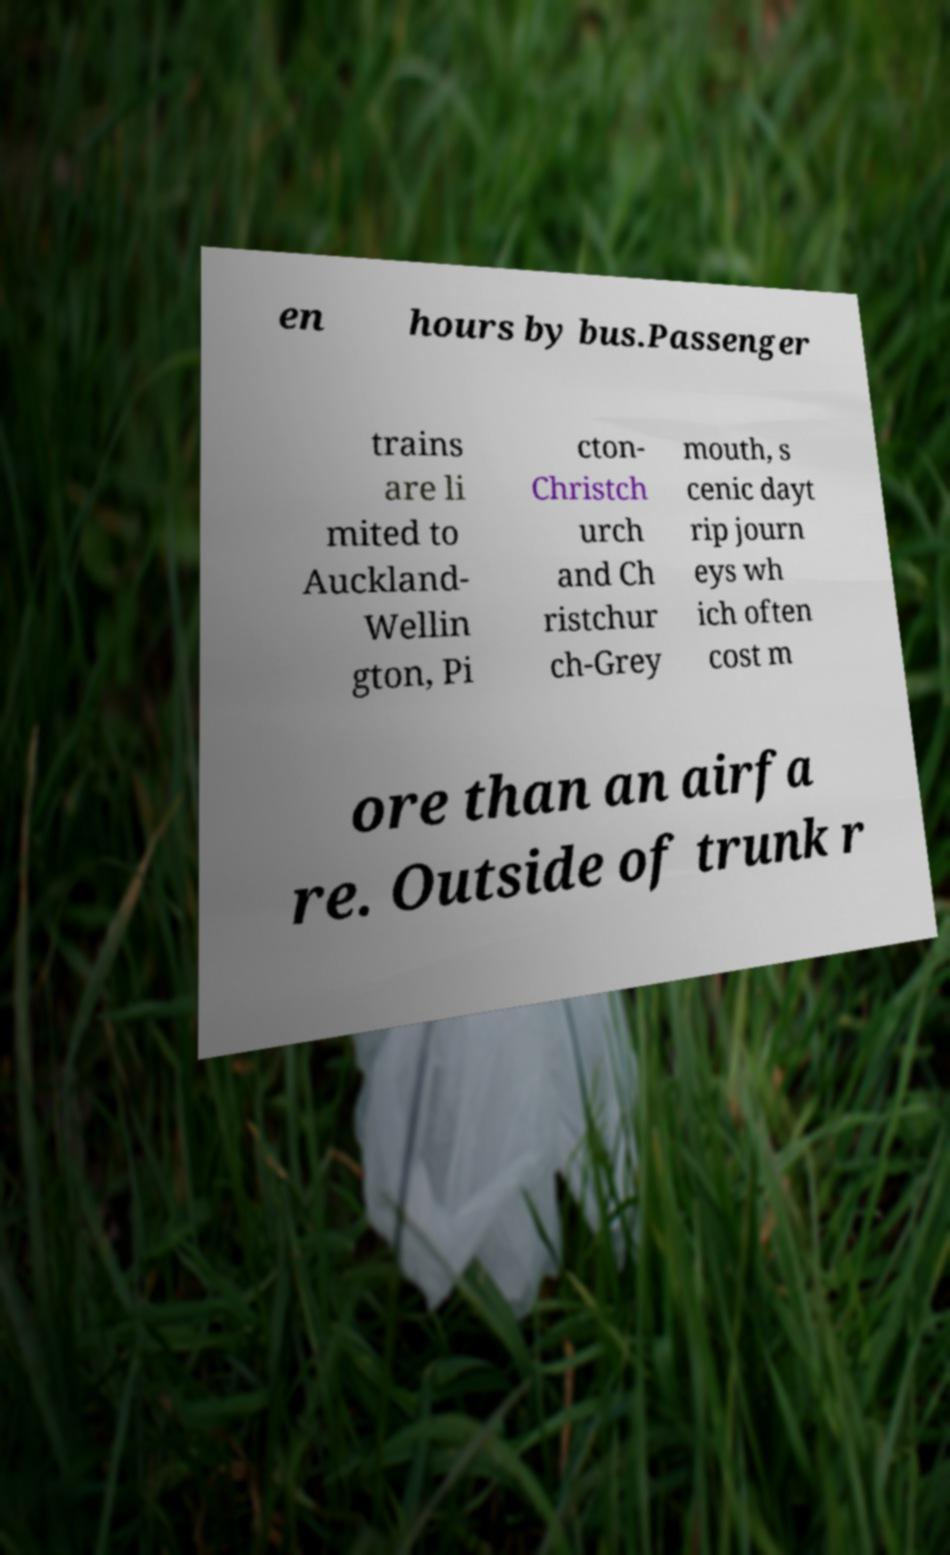Could you assist in decoding the text presented in this image and type it out clearly? en hours by bus.Passenger trains are li mited to Auckland- Wellin gton, Pi cton- Christch urch and Ch ristchur ch-Grey mouth, s cenic dayt rip journ eys wh ich often cost m ore than an airfa re. Outside of trunk r 